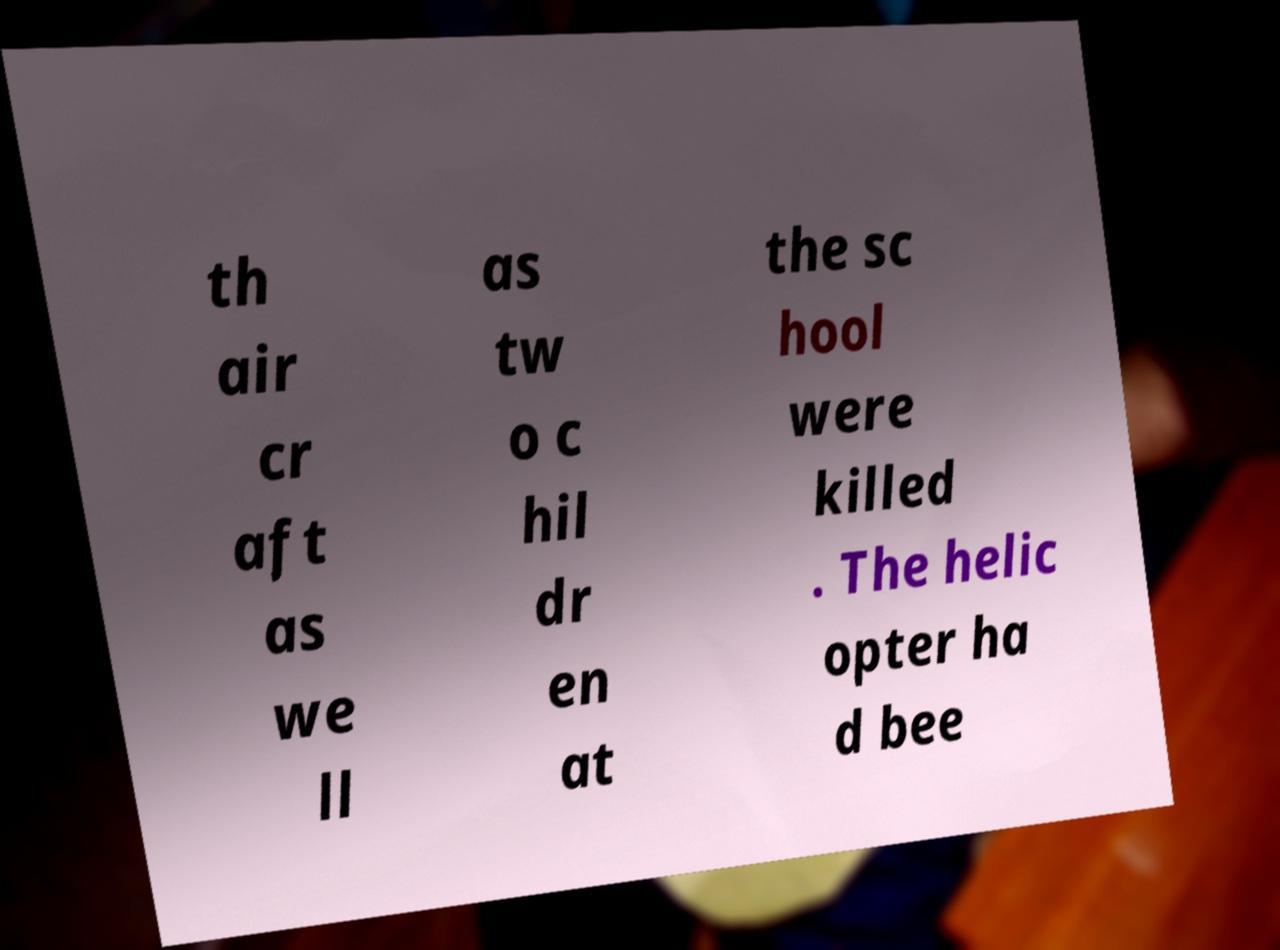Can you accurately transcribe the text from the provided image for me? th air cr aft as we ll as tw o c hil dr en at the sc hool were killed . The helic opter ha d bee 